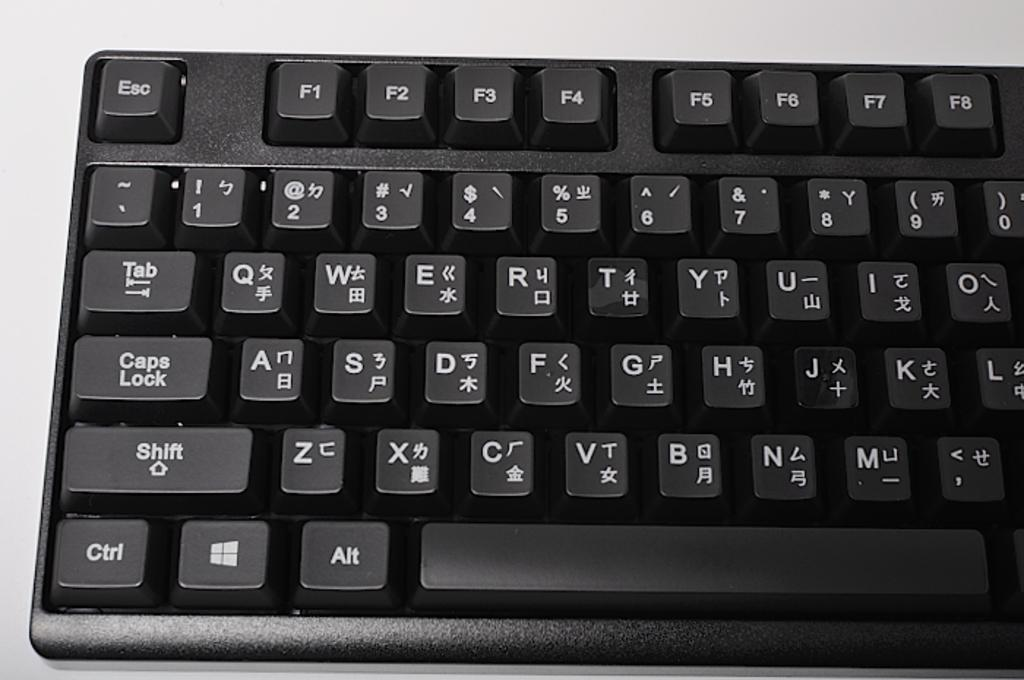<image>
Create a compact narrative representing the image presented. The Tab and Caps lock keys of a keyboard are shown on a black keyboard. 